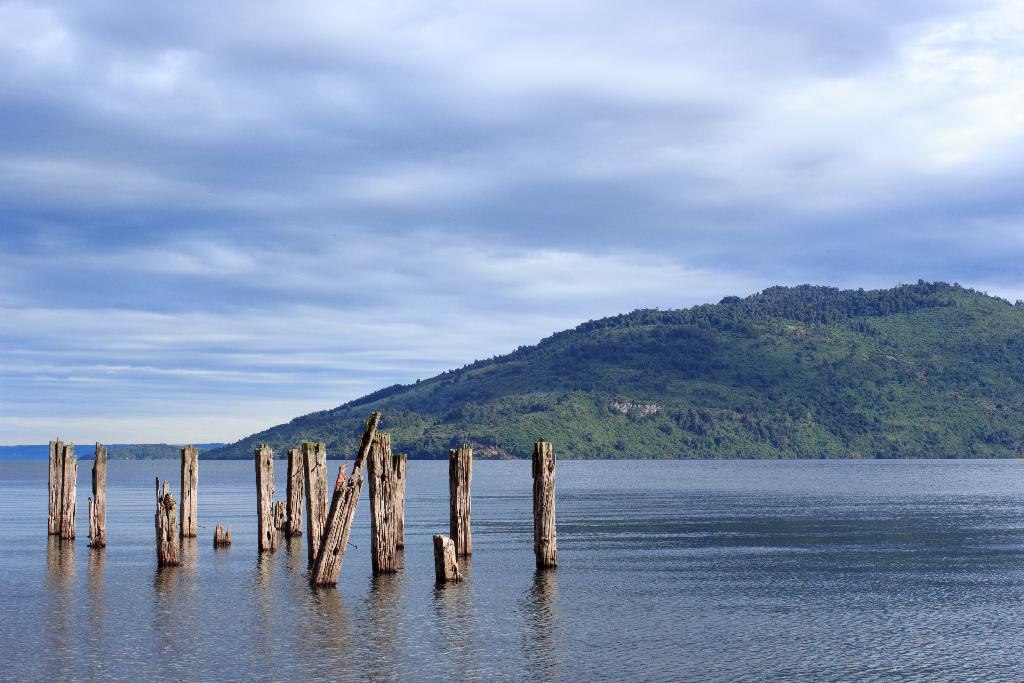What is on the water in the image? There are stocks on the water in the image. What can be seen in the distance in the image? There is a hill visible in the background of the image. What else is visible in the background of the image? There is water and the sky visible in the background of the image. What is the condition of the sky in the image? Clouds are present in the sky. What type of car can be seen driving on the water in the image? There is no car present in the image; it features stocks on the water. What statement is being made by the stocks in the image? The image does not contain any statements or messages; it is a visual representation of stocks on the water. 